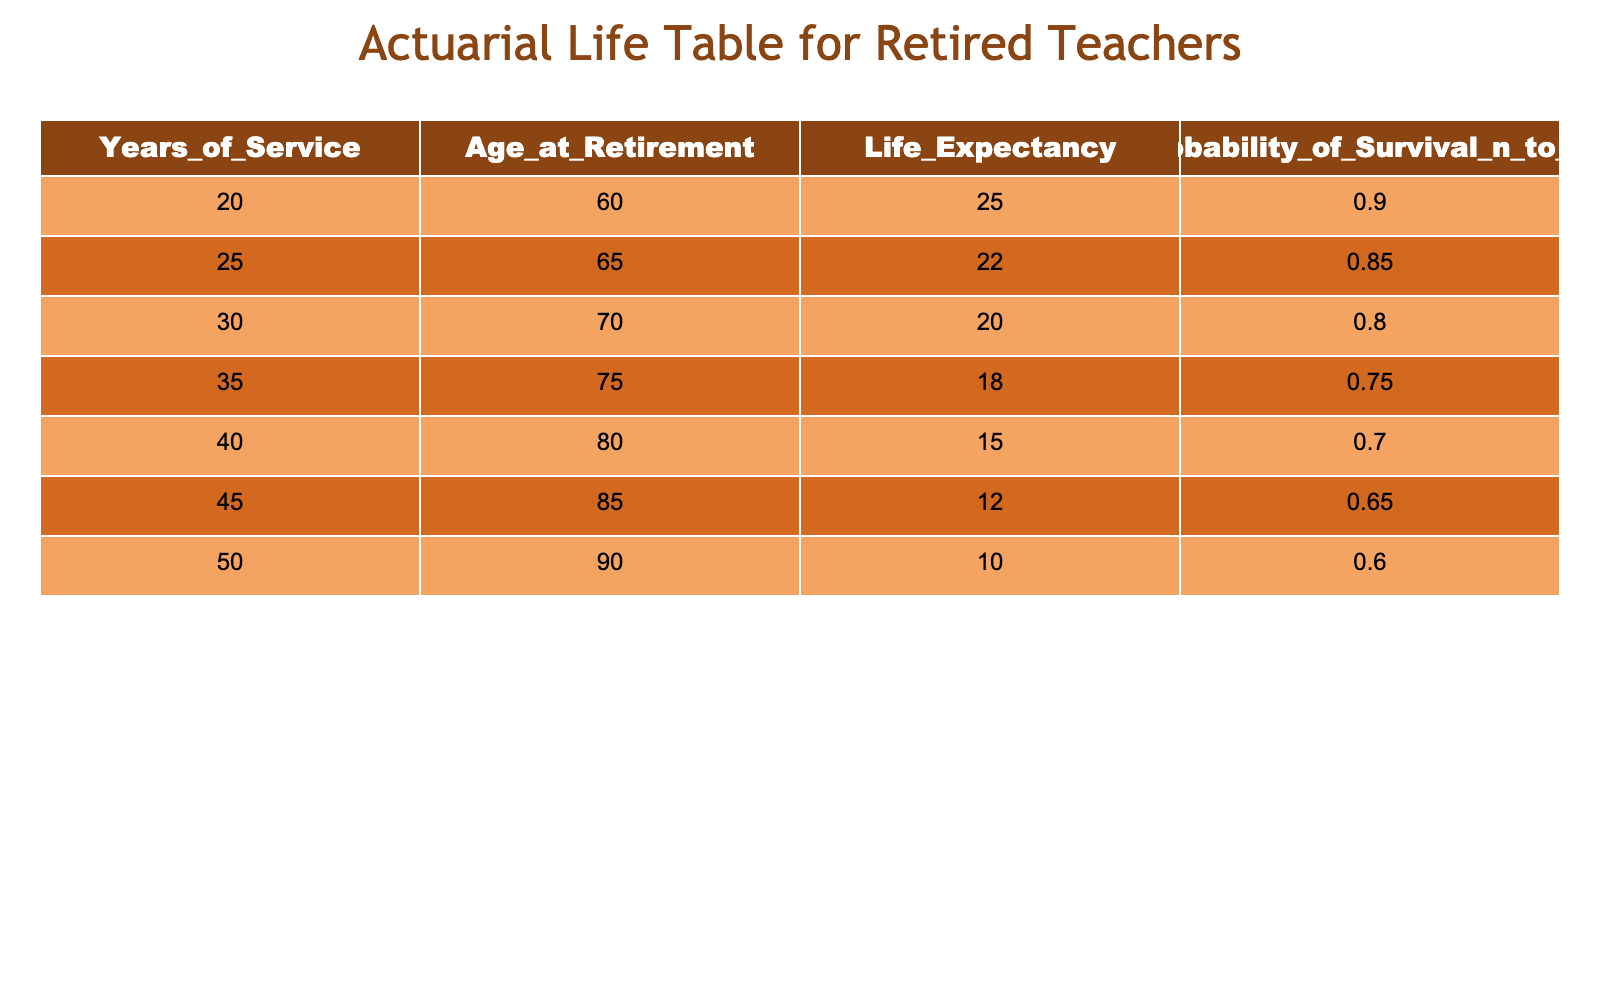What is the life expectancy of a retired teacher who has served for 20 years? The table indicates that the life expectancy of a retired teacher with 20 years of service is listed directly. According to the data, the life expectancy for this group is 25 years.
Answer: 25 years What is the probability of survival for a retired teacher at 70 years of age? Looking at the table, a retired teacher who is 70 years old corresponds to 30 years of service. The probability of survival for this age group is 0.80.
Answer: 0.80 How much longer can a retired teacher who has served 35 years expect to live compared to one who has served 20 years? The table shows that the life expectancy for a retired teacher with 35 years of service is 18 years, while for someone with 20 years of service, it is 25 years. The difference can be calculated as 25 - 18 = 7 years.
Answer: 7 years Is the probability of survival for a retired teacher who has served 40 years greater than that for someone with 25 years of service? According to the table, the probability of survival for someone with 40 years of service is 0.70, while for 25 years it is 0.85. Thus, 0.70 is less than 0.85, meaning the statement is false.
Answer: No Calculate the average life expectancy for teachers who have served 25 years or more. The life expectancies for teachers with 25, 30, 35, 40, 45, and 50 years of service are 22, 20, 18, 15, 12, and 10 respectively. Adding these gives 22 + 20 + 18 + 15 + 12 + 10 = 107. There are 6 data points, so the average is 107 / 6 ≈ 17.83 years.
Answer: Approximately 17.83 years Which group has the highest probability of survival, and what is that probability? By examining the probability of survival across all groups, the highest value is for the 20 years of service group at 0.90. Therefore, this group has the highest probability of survival.
Answer: 0.90 What is the life expectancy of a retired teacher who has served 50 years compared to one who has served 35 years? From the table, the life expectancy for a teacher with 50 years of service is 10 years, while for someone with 35 years of service, it is 18 years. Comparing these shows that 10 is less than 18, meaning the teacher with 50 years has a shorter life expectancy.
Answer: 10 years and 18 years (50 years less than 35 years) Is it true that retiring after 45 years of service leads to a life expectancy of at least 12 years? The table indicates that the life expectancy for someone retiring after 45 years of service is 12 years exactly, which means the statement is true.
Answer: Yes 